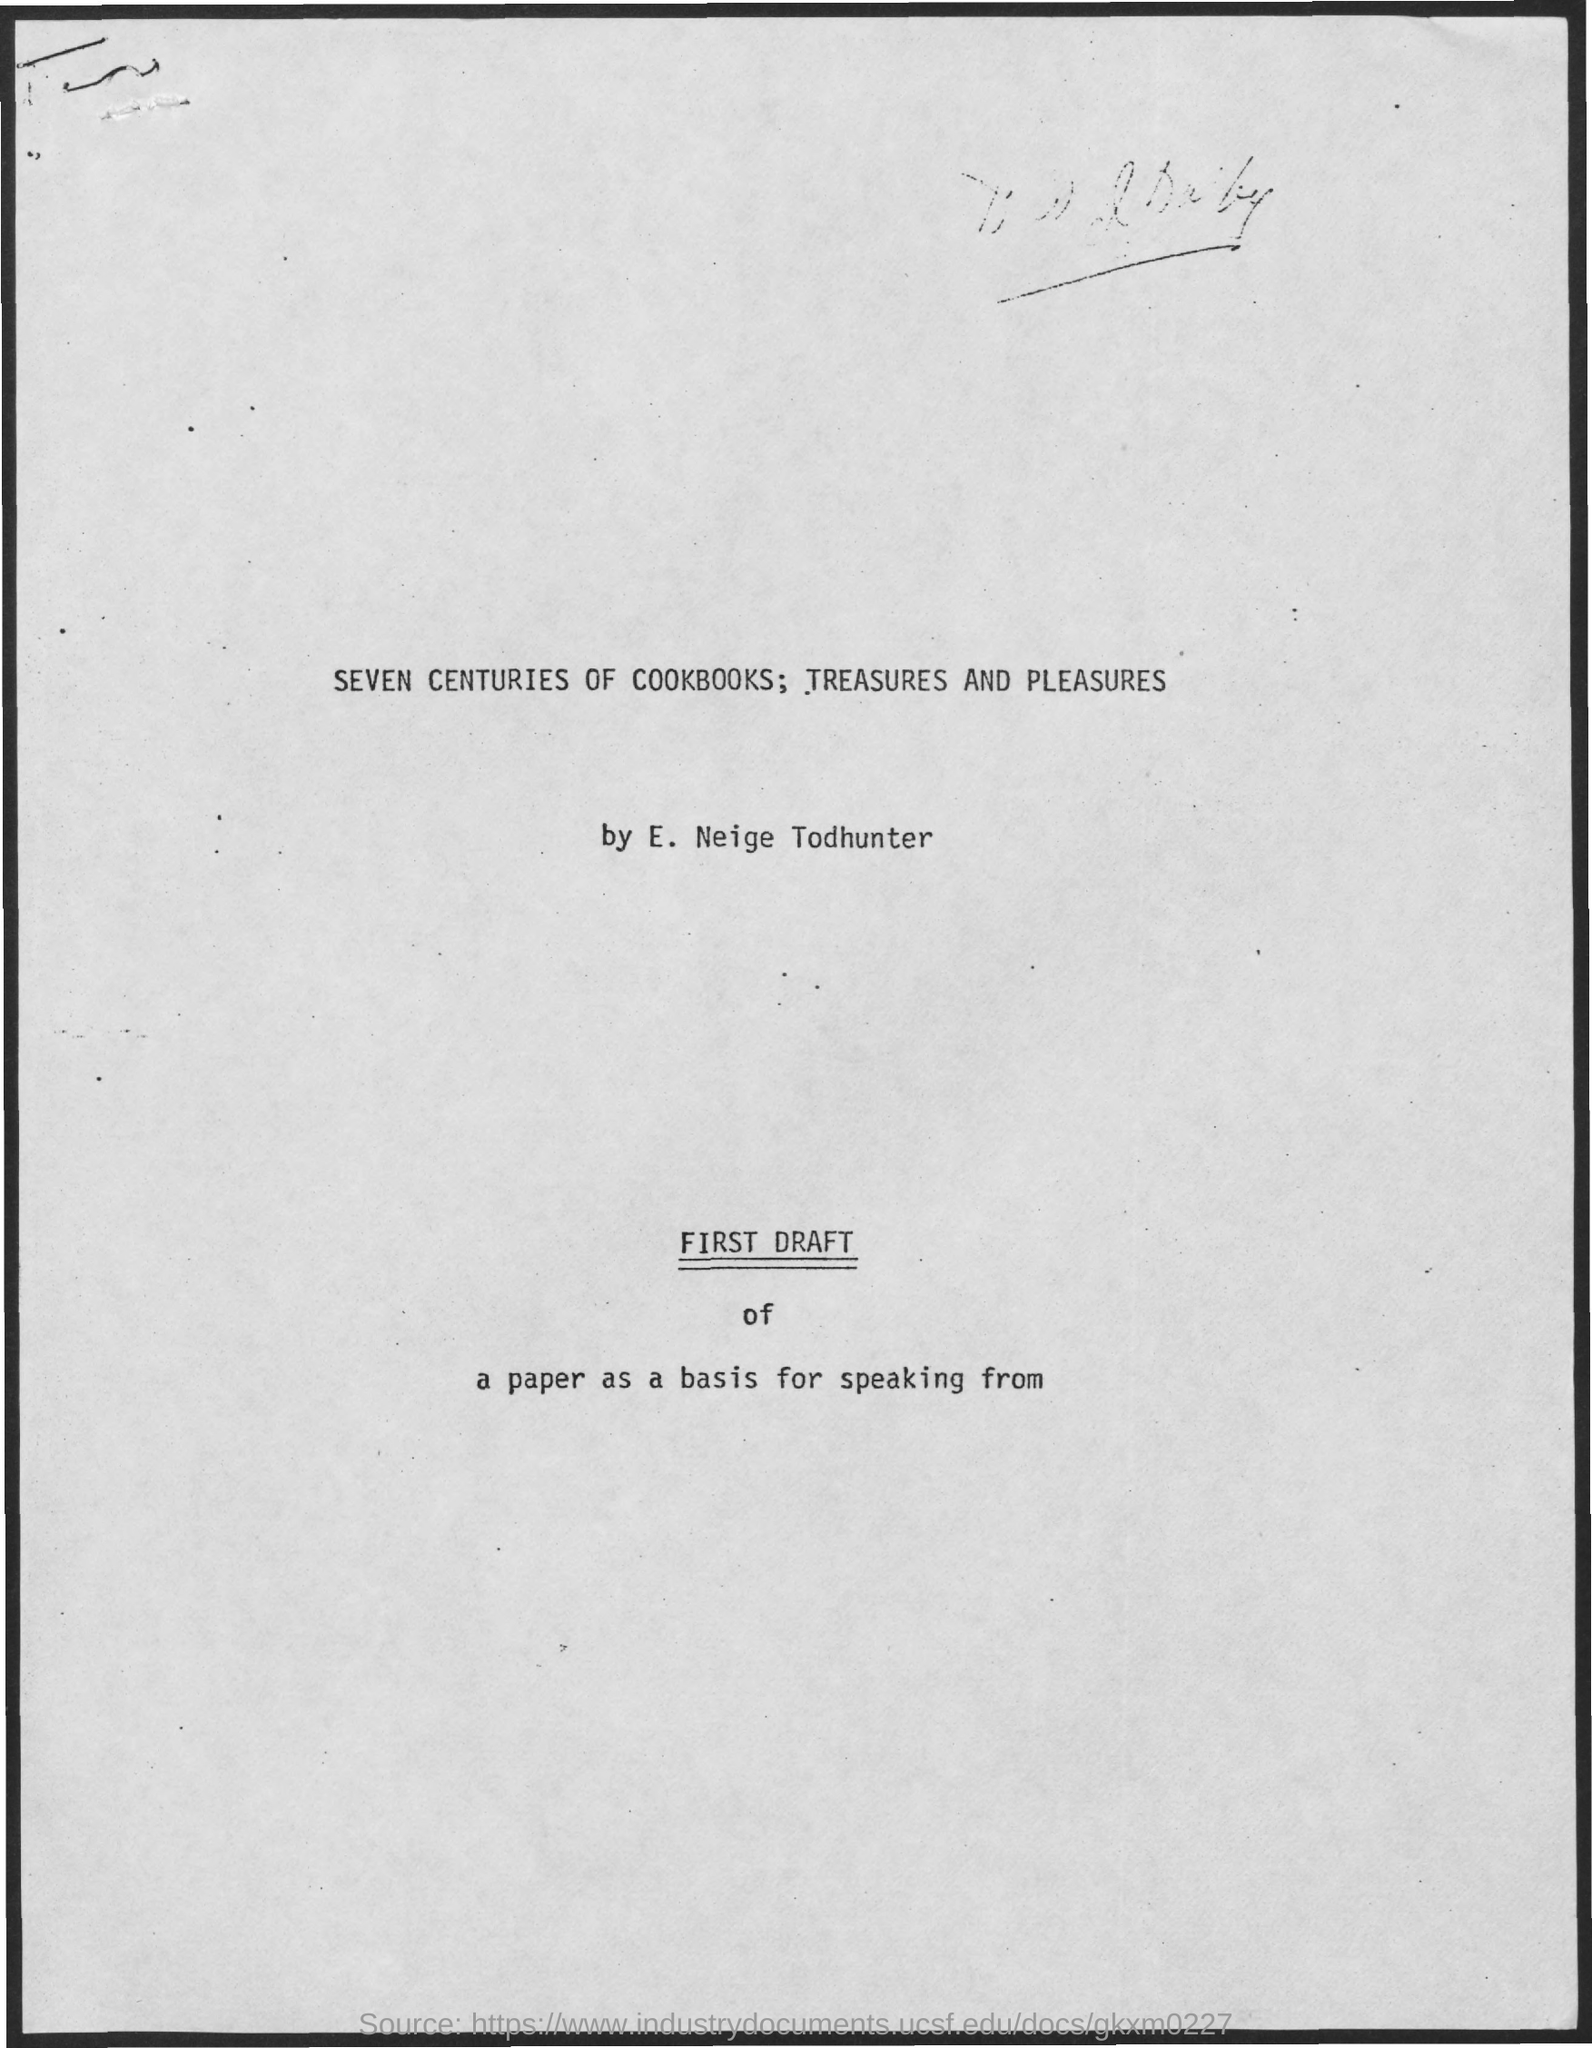What is the title of the document?
Your answer should be very brief. Seven centuries of cookbooks, treasures and pleasures. Which person submitted the report?
Your response must be concise. E. Neige Todhunter. 